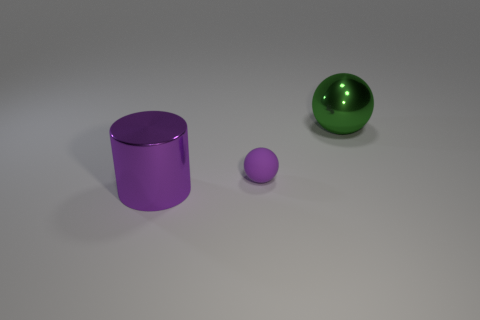Is there anything else that is the same shape as the big purple shiny thing?
Your answer should be compact. No. Is there a metallic cylinder of the same color as the small thing?
Keep it short and to the point. Yes. What is the color of the thing that is the same size as the purple cylinder?
Make the answer very short. Green. There is a big metallic thing that is in front of the large green object; does it have the same color as the small object?
Keep it short and to the point. Yes. Are there any big gray objects made of the same material as the large sphere?
Provide a succinct answer. No. There is a thing that is the same color as the large cylinder; what is its shape?
Ensure brevity in your answer.  Sphere. Are there fewer big spheres that are in front of the purple metallic object than small gray rubber things?
Your answer should be very brief. No. Does the metal object that is to the left of the rubber object have the same size as the purple rubber ball?
Provide a short and direct response. No. What number of big green things have the same shape as the large purple shiny thing?
Offer a terse response. 0. There is a object that is the same material as the green ball; what size is it?
Your answer should be compact. Large. 